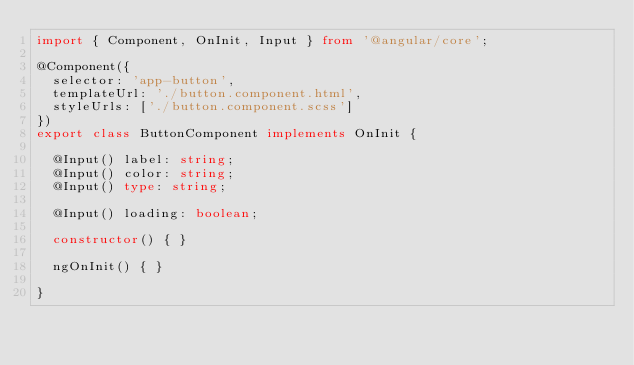Convert code to text. <code><loc_0><loc_0><loc_500><loc_500><_TypeScript_>import { Component, OnInit, Input } from '@angular/core';

@Component({
  selector: 'app-button',
  templateUrl: './button.component.html',
  styleUrls: ['./button.component.scss']
})
export class ButtonComponent implements OnInit {

  @Input() label: string;
  @Input() color: string;
  @Input() type: string;

  @Input() loading: boolean;

  constructor() { }

  ngOnInit() { }

}
</code> 